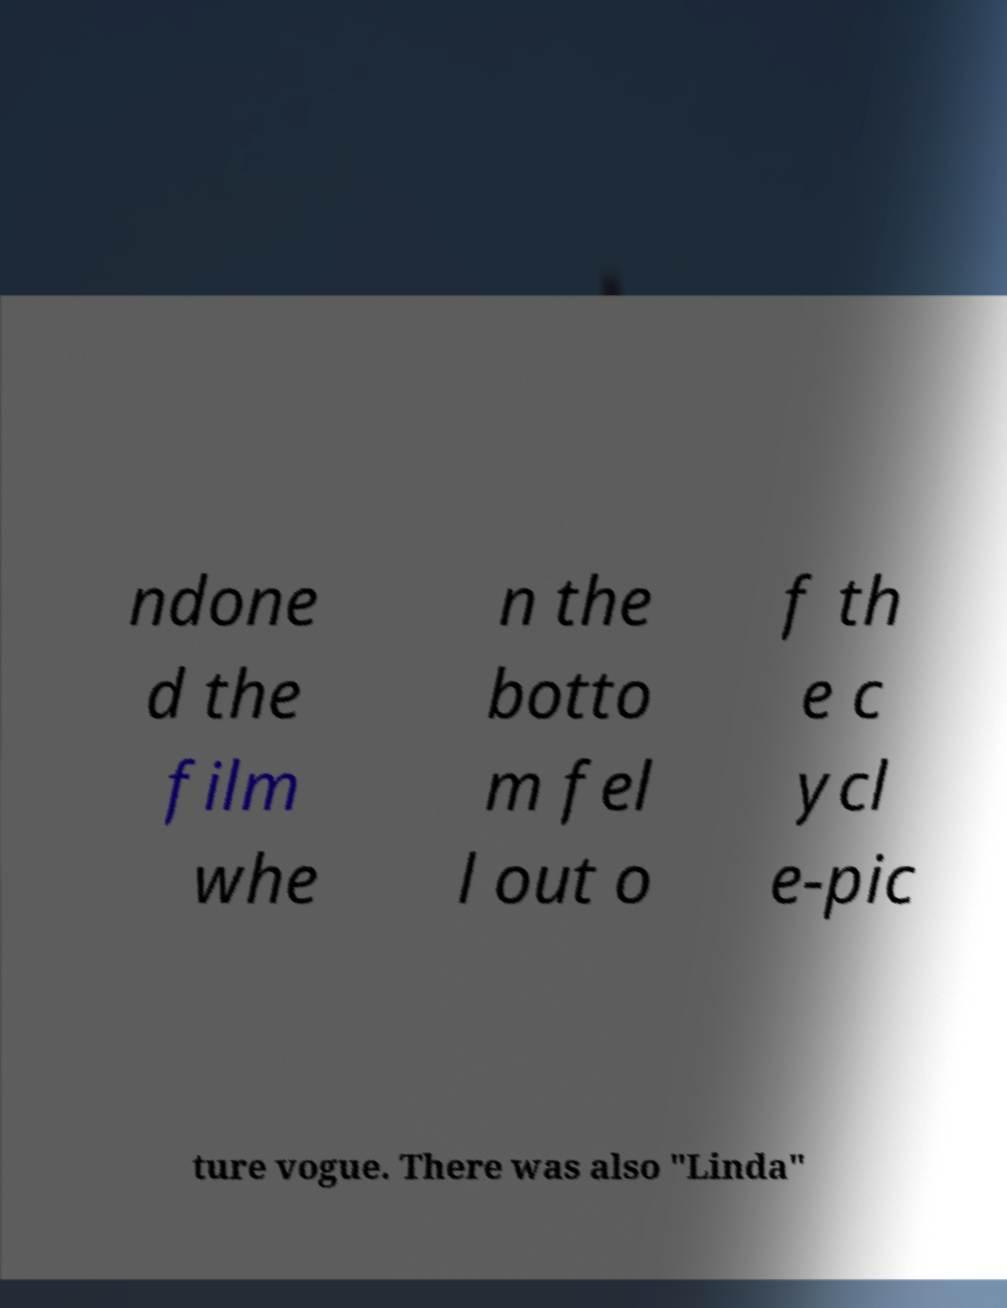For documentation purposes, I need the text within this image transcribed. Could you provide that? ndone d the film whe n the botto m fel l out o f th e c ycl e-pic ture vogue. There was also "Linda" 